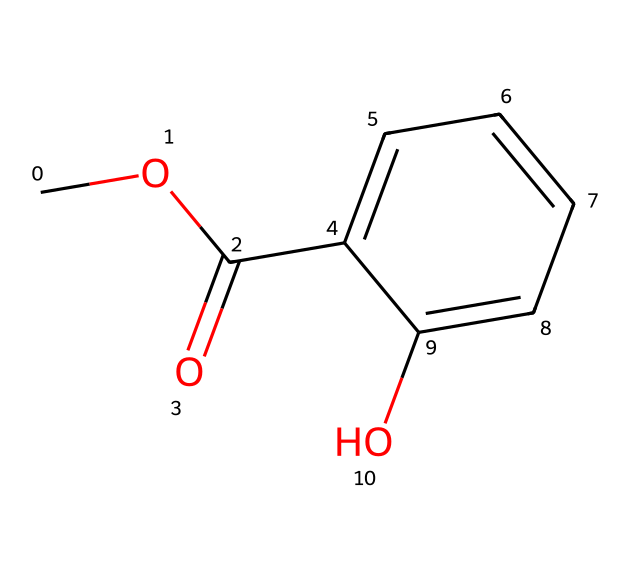What is the molecular formula of methyl salicylate? The molecular formula can be derived from the chemical structure by identifying the number of each type of atom present in the SMILES representation. In this case, we count 9 carbons (C), 10 hydrogens (H), and 4 oxygens (O), resulting in the formula C9H10O4.
Answer: C9H10O4 How many carbon atoms are present in methyl salicylate? By examining the SMILES representation, we can count the number of carbon (C) atoms indicated in the structure. There are a total of 9 carbon atoms in this compound.
Answer: 9 What type of functional groups are present in methyl salicylate? The SMILES notation reveals the presence of both an ester functional group (C(=O)O) and a hydroxyl group (–OH) attached to the aromatic ring. The ester group is characteristic for esters, while the hydroxyl brings in alcohol characteristics.
Answer: ester, hydroxyl Does methyl salicylate have aromatic properties? The presence of a benzene ring in the structure (indicated by the presence of alternating C=C bonds) suggests that this molecule has aromatic properties. Since physical and chemical characteristics of aromatic compounds include stability and distinctive scents, and methyl salicylate is known for its wintergreen scent, it can be confirmed it possesses aromatic qualities.
Answer: yes What is the total number of hydrogen bonds in methyl salicylate? To determine the number of hydrogen atoms in the methyl salicylate, we count the hydrogen atoms attached to each functional group and carbon atom in the structure. The total comes to 10 hydrogen atoms, so the molecule has a total of 10 hydrogen-bound positions.
Answer: 10 What role does the ester group play in the properties of methyl salicylate? The ester functional group is key in defining the behavior of the molecule in terms of its reactivity and scent properties. This group is responsible for the compound being classified as an ester, which contributes to its characteristic odor and its use in flavoring and fragrance applications.
Answer: contributes scent and flavor How does the presence of hydroxyl group affect the solubility of methyl salicylate? The presence of the hydroxyl group (–OH) generally increases the polarity of the molecule, making it more hydrophilic compared to molecules without such groups. This can enhance its solubility in polar solvents, such as water, while also influencing its behavior in organic solvents.
Answer: increases solubility 